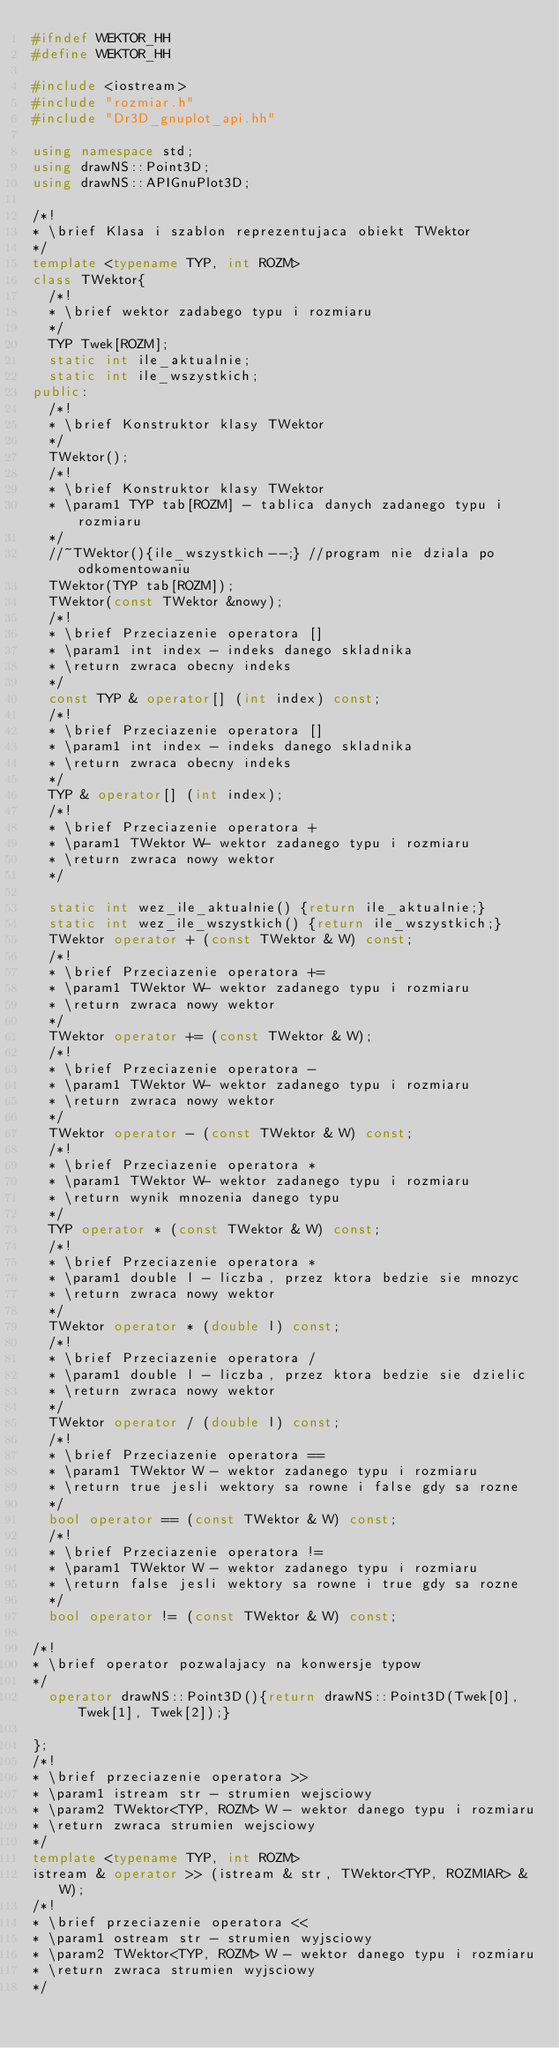<code> <loc_0><loc_0><loc_500><loc_500><_C++_>#ifndef WEKTOR_HH
#define WEKTOR_HH

#include <iostream>
#include "rozmiar.h"
#include "Dr3D_gnuplot_api.hh"

using namespace std;
using drawNS::Point3D;
using drawNS::APIGnuPlot3D;

/*!
* \brief Klasa i szablon reprezentujaca obiekt TWektor
*/
template <typename TYP, int ROZM>
class TWektor{
  /*!
  * \brief wektor zadabego typu i rozmiaru
  */
  TYP Twek[ROZM];
  static int ile_aktualnie;
  static int ile_wszystkich;
public:
  /*!
  * \brief Konstruktor klasy TWektor
  */
  TWektor();
  /*!
  * \brief Konstruktor klasy TWektor
  * \param1 TYP tab[ROZM] - tablica danych zadanego typu i rozmiaru
  */
  //~TWektor(){ile_wszystkich--;} //program nie dziala po odkomentowaniu
  TWektor(TYP tab[ROZM]);
  TWektor(const TWektor &nowy);
  /*!
  * \brief Przeciazenie operatora []
  * \param1 int index - indeks danego skladnika
  * \return zwraca obecny indeks
  */
  const TYP & operator[] (int index) const;
  /*!
  * \brief Przeciazenie operatora []
  * \param1 int index - indeks danego skladnika
  * \return zwraca obecny indeks
  */
  TYP & operator[] (int index);
  /*!
  * \brief Przeciazenie operatora +
  * \param1 TWektor W- wektor zadanego typu i rozmiaru
  * \return zwraca nowy wektor
  */

  static int wez_ile_aktualnie() {return ile_aktualnie;}
  static int wez_ile_wszystkich() {return ile_wszystkich;}
  TWektor operator + (const TWektor & W) const;
  /*!
  * \brief Przeciazenie operatora +=
  * \param1 TWektor W- wektor zadanego typu i rozmiaru
  * \return zwraca nowy wektor
  */
  TWektor operator += (const TWektor & W);
  /*!
  * \brief Przeciazenie operatora -
  * \param1 TWektor W- wektor zadanego typu i rozmiaru
  * \return zwraca nowy wektor
  */
  TWektor operator - (const TWektor & W) const;
  /*!
  * \brief Przeciazenie operatora *
  * \param1 TWektor W- wektor zadanego typu i rozmiaru
  * \return wynik mnozenia danego typu
  */
  TYP operator * (const TWektor & W) const;
  /*!
  * \brief Przeciazenie operatora *
  * \param1 double l - liczba, przez ktora bedzie sie mnozyc
  * \return zwraca nowy wektor
  */
  TWektor operator * (double l) const;
  /*!
  * \brief Przeciazenie operatora /
  * \param1 double l - liczba, przez ktora bedzie sie dzielic
  * \return zwraca nowy wektor
  */
  TWektor operator / (double l) const;
  /*!
  * \brief Przeciazenie operatora ==
  * \param1 TWektor W - wektor zadanego typu i rozmiaru
  * \return true jesli wektory sa rowne i false gdy sa rozne
  */
  bool operator == (const TWektor & W) const;
  /*!
  * \brief Przeciazenie operatora !=
  * \param1 TWektor W - wektor zadanego typu i rozmiaru
  * \return false jesli wektory sa rowne i true gdy sa rozne
  */
  bool operator != (const TWektor & W) const;

/*!
* \brief operator pozwalajacy na konwersje typow
*/
  operator drawNS::Point3D(){return drawNS::Point3D(Twek[0],Twek[1], Twek[2]);}

};
/*!
* \brief przeciazenie operatora >>
* \param1 istream str - strumien wejsciowy
* \param2 TWektor<TYP, ROZM> W - wektor danego typu i rozmiaru
* \return zwraca strumien wejsciowy
*/
template <typename TYP, int ROZM>
istream & operator >> (istream & str, TWektor<TYP, ROZMIAR> & W);
/*!
* \brief przeciazenie operatora <<
* \param1 ostream str - strumien wyjsciowy
* \param2 TWektor<TYP, ROZM> W - wektor danego typu i rozmiaru
* \return zwraca strumien wyjsciowy
*/</code> 